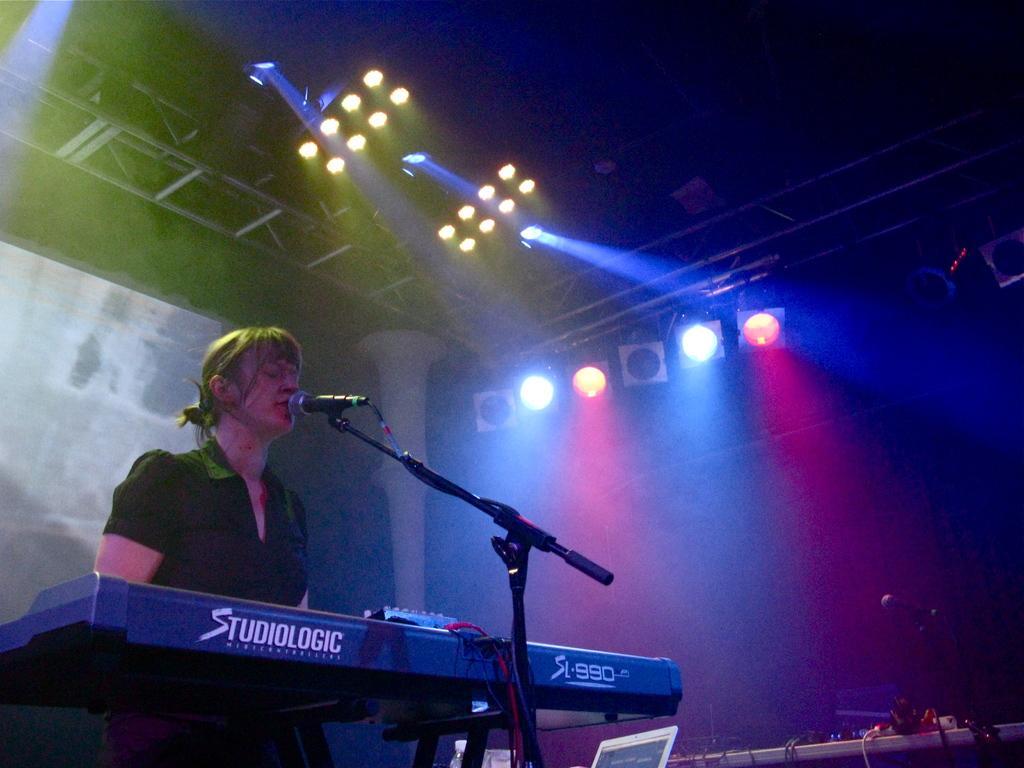Please provide a concise description of this image. In this image there is a person standing, there are miles with the miles stands, there is a piano board, there are some objects on the table,and in the background there are focus lights ,screen and lighting truss. 